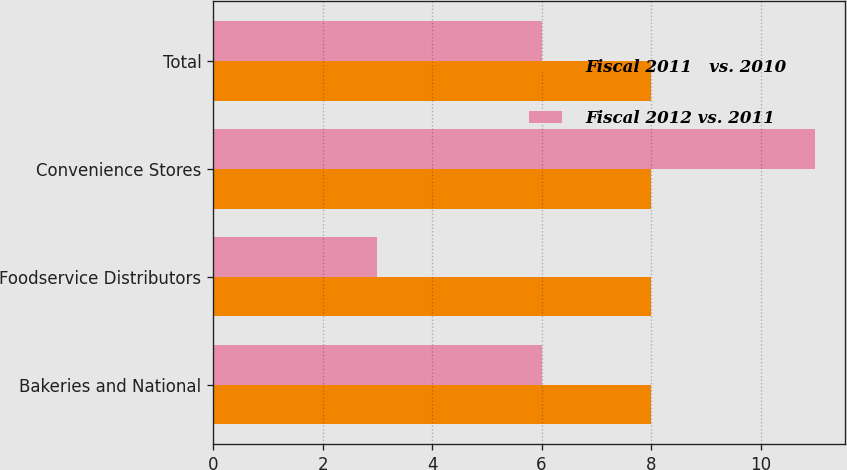Convert chart to OTSL. <chart><loc_0><loc_0><loc_500><loc_500><stacked_bar_chart><ecel><fcel>Bakeries and National<fcel>Foodservice Distributors<fcel>Convenience Stores<fcel>Total<nl><fcel>Fiscal 2011   vs. 2010<fcel>8<fcel>8<fcel>8<fcel>8<nl><fcel>Fiscal 2012 vs. 2011<fcel>6<fcel>3<fcel>11<fcel>6<nl></chart> 